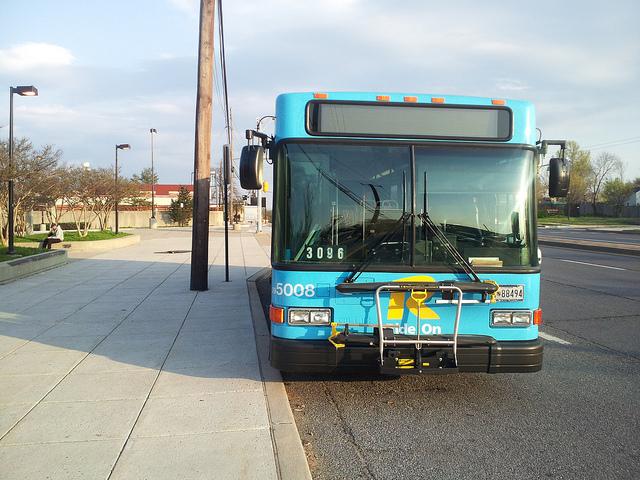What color is the bus?
Concise answer only. Blue. Does this bus have a known destination?
Short answer required. No. What number is on the windshield of the bus?
Answer briefly. 3096. 